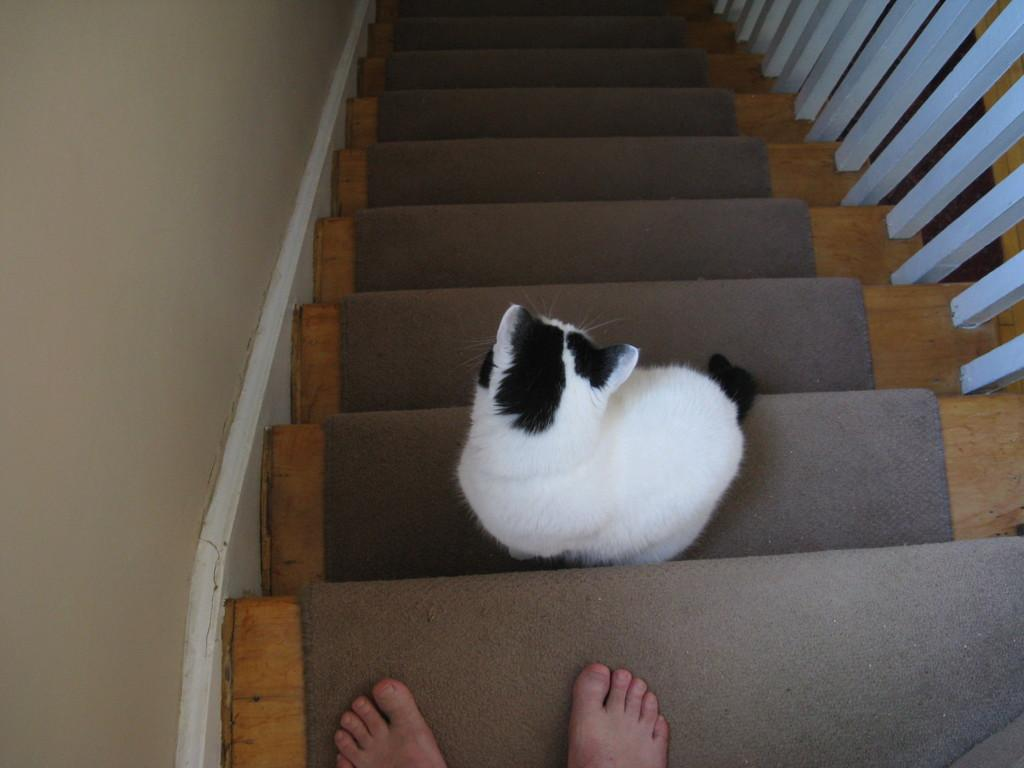What animal is present in the foreground of the image? There is a cat on a stair in the foreground. What architectural feature is visible in the image? There are stairs at the top side of the image. Can you describe the presence of a person in the image? There are two legs of a person at the bottom side of the image. What type of pet bird is sitting on the cat's head in the image? There is no pet bird present in the image, nor is there a bird sitting on the cat's head. 